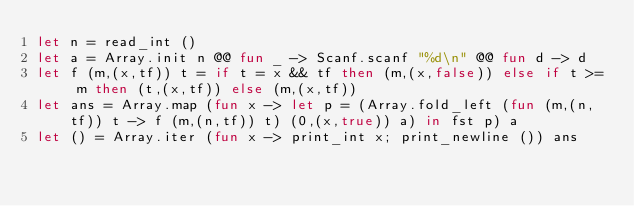Convert code to text. <code><loc_0><loc_0><loc_500><loc_500><_OCaml_>let n = read_int ()
let a = Array.init n @@ fun _ -> Scanf.scanf "%d\n" @@ fun d -> d
let f (m,(x,tf)) t = if t = x && tf then (m,(x,false)) else if t >= m then (t,(x,tf)) else (m,(x,tf))
let ans = Array.map (fun x -> let p = (Array.fold_left (fun (m,(n,tf)) t -> f (m,(n,tf)) t) (0,(x,true)) a) in fst p) a
let () = Array.iter (fun x -> print_int x; print_newline ()) ans</code> 